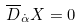<formula> <loc_0><loc_0><loc_500><loc_500>\overline { D } _ { \dot { \alpha } } X = 0</formula> 